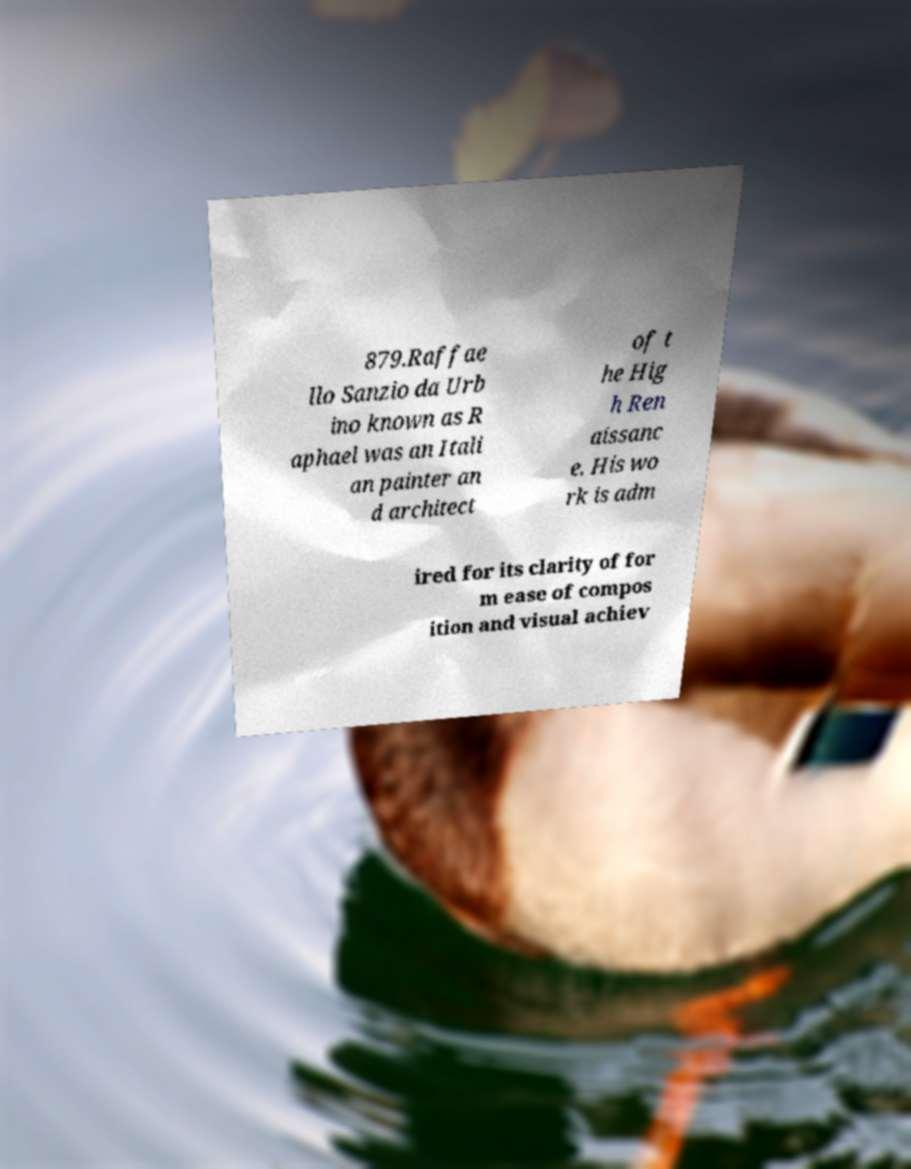Please identify and transcribe the text found in this image. 879.Raffae llo Sanzio da Urb ino known as R aphael was an Itali an painter an d architect of t he Hig h Ren aissanc e. His wo rk is adm ired for its clarity of for m ease of compos ition and visual achiev 